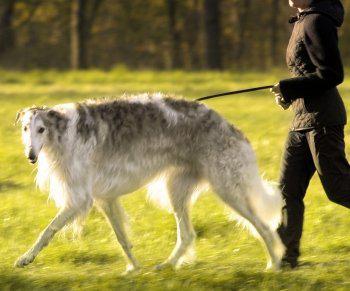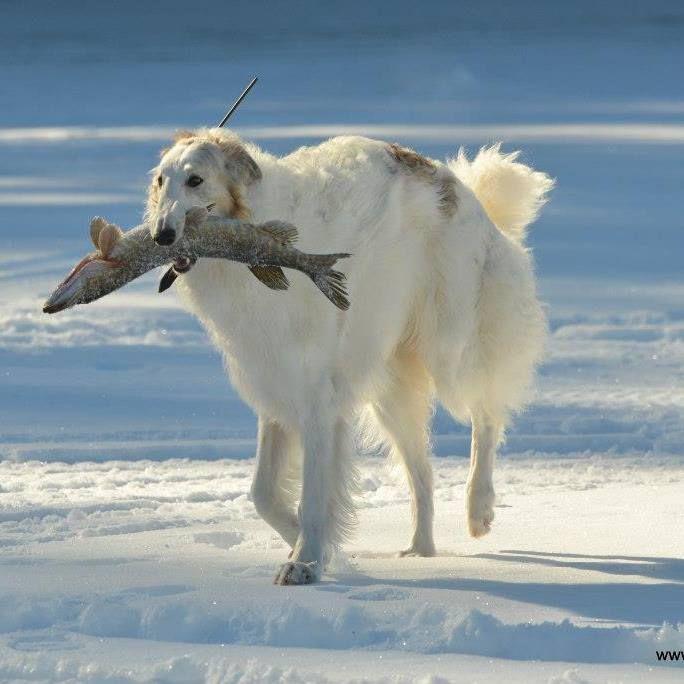The first image is the image on the left, the second image is the image on the right. Assess this claim about the two images: "There are at most two dogs.". Correct or not? Answer yes or no. Yes. The first image is the image on the left, the second image is the image on the right. Examine the images to the left and right. Is the description "At least one of the dogs is near a body of water." accurate? Answer yes or no. No. 